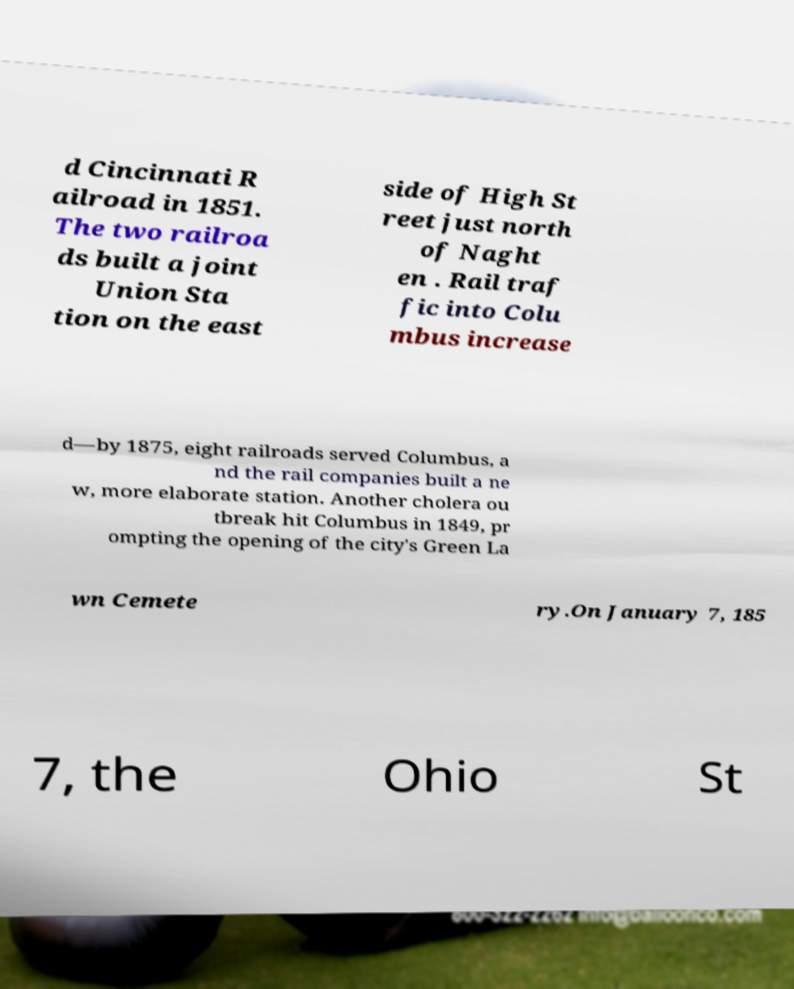Can you read and provide the text displayed in the image?This photo seems to have some interesting text. Can you extract and type it out for me? d Cincinnati R ailroad in 1851. The two railroa ds built a joint Union Sta tion on the east side of High St reet just north of Naght en . Rail traf fic into Colu mbus increase d—by 1875, eight railroads served Columbus, a nd the rail companies built a ne w, more elaborate station. Another cholera ou tbreak hit Columbus in 1849, pr ompting the opening of the city's Green La wn Cemete ry.On January 7, 185 7, the Ohio St 